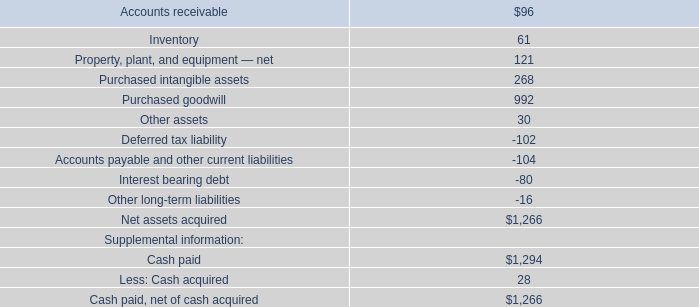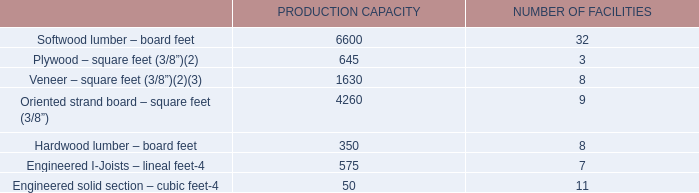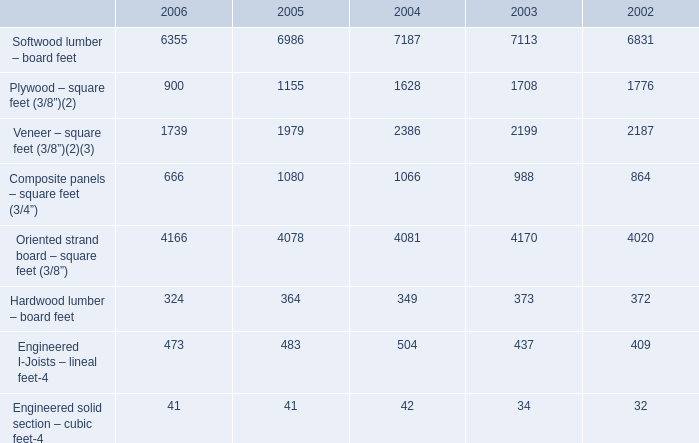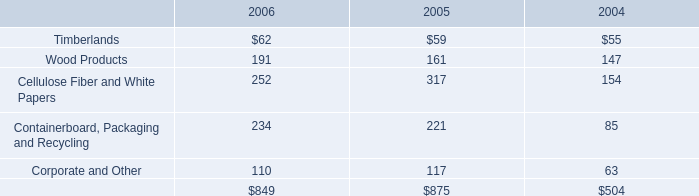What is the proportion of Softwood lumber – board feet to the total for PRODUCTION CAPACITY? 
Computations: (6600 / ((((((6600 + 645) + 1630) + 4260) + 350) + 575) + 50))
Answer: 0.46775. 